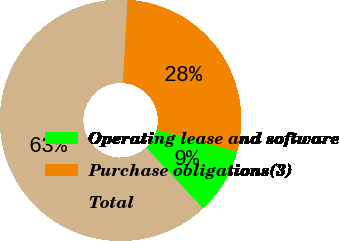Convert chart. <chart><loc_0><loc_0><loc_500><loc_500><pie_chart><fcel>Operating lease and software<fcel>Purchase obligations(3)<fcel>Total<nl><fcel>8.87%<fcel>28.26%<fcel>62.87%<nl></chart> 